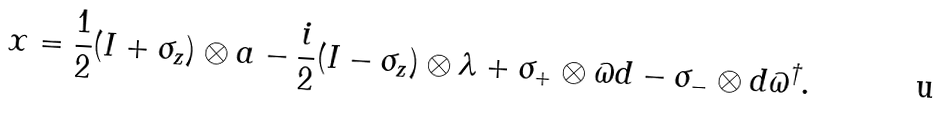<formula> <loc_0><loc_0><loc_500><loc_500>x = \frac { 1 } { 2 } ( I + \sigma _ { z } ) \otimes a - \frac { i } { 2 } ( I - \sigma _ { z } ) \otimes \lambda + \sigma _ { + } \otimes \varpi d - \sigma _ { - } \otimes d \varpi ^ { \dagger } .</formula> 